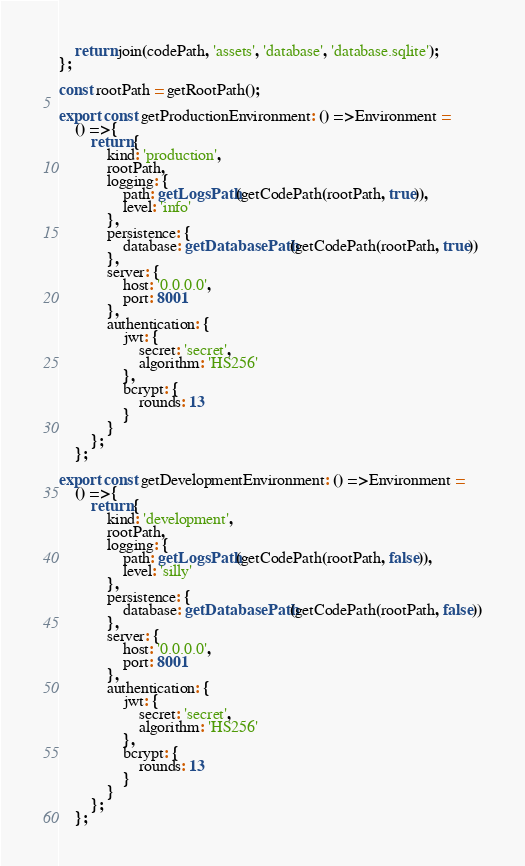Convert code to text. <code><loc_0><loc_0><loc_500><loc_500><_TypeScript_>    return join(codePath, 'assets', 'database', 'database.sqlite');
};

const rootPath = getRootPath();

export const getProductionEnvironment: () => Environment = 
    () => {
        return {
            kind: 'production',
            rootPath,
            logging: {
                path: getLogsPath(getCodePath(rootPath, true)),
                level: 'info'
            },
            persistence: {
                database: getDatabasePath(getCodePath(rootPath, true))
            },
            server: {
                host: '0.0.0.0',
                port: 8001
            },
            authentication: {
                jwt: {
                    secret: 'secret',
                    algorithm: 'HS256'
                },
                bcrypt: {
                    rounds: 13
                }
            }
        };
    };

export const getDevelopmentEnvironment: () => Environment = 
    () => {
        return {
            kind: 'development',
            rootPath,
            logging: {
                path: getLogsPath(getCodePath(rootPath, false)),
                level: 'silly'
            },
            persistence: {
                database: getDatabasePath(getCodePath(rootPath, false))
            },
            server: {
                host: '0.0.0.0',
                port: 8001
            },
            authentication: {
                jwt: {
                    secret: 'secret',
                    algorithm: 'HS256'
                },
                bcrypt: {
                    rounds: 13
                }
            }
        };
    };</code> 